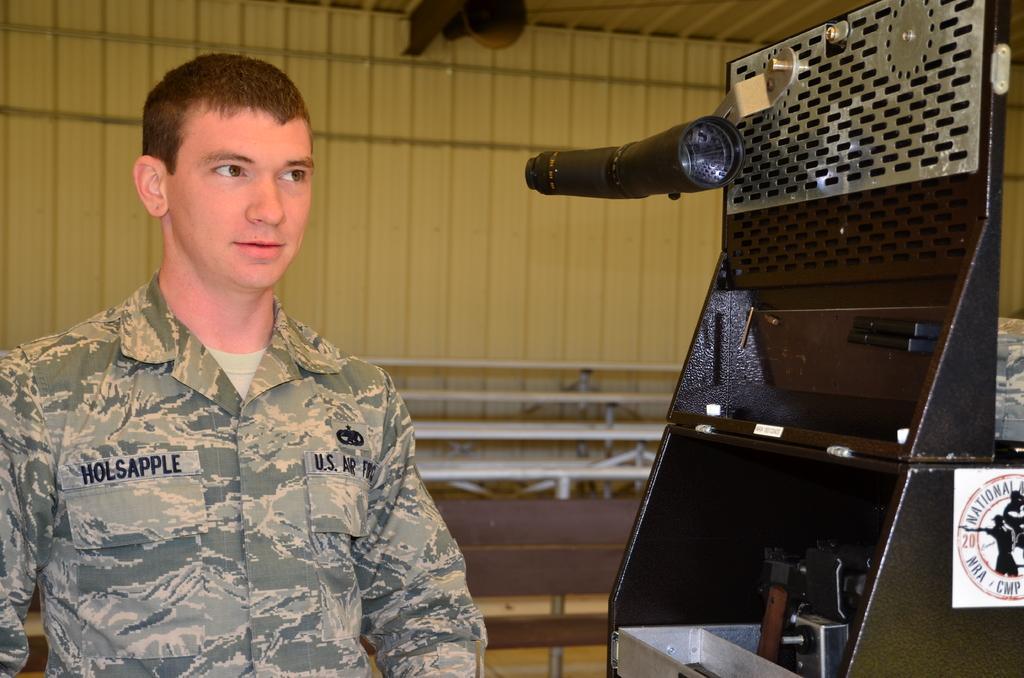Can you describe this image briefly? In this image in front there is a person. Beside him there is some object. Behind him there is a table. In the background of the image there is a wall. In front of the wall there is some object. On top of the image there is a speaker. 